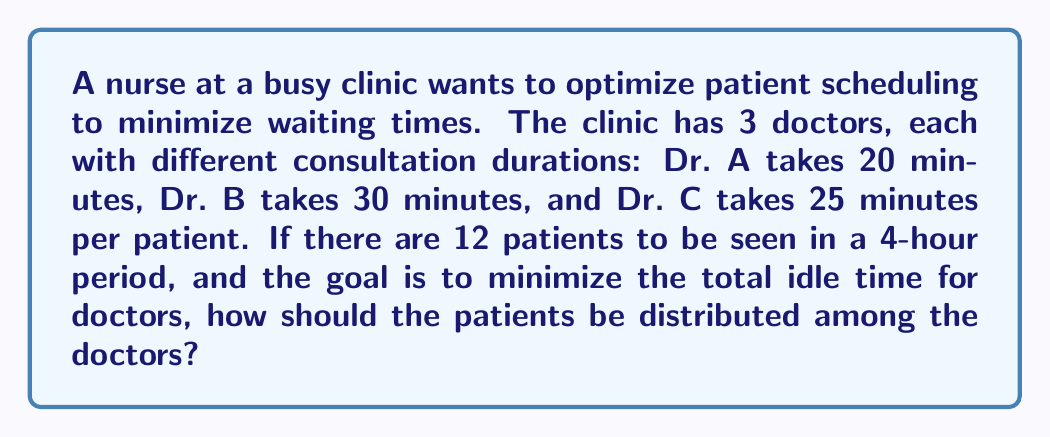Solve this math problem. To solve this problem, we need to follow these steps:

1. Calculate the total available time for all doctors:
   $4 \text{ hours} = 240 \text{ minutes}$

2. Set up variables:
   Let $x$, $y$, and $z$ be the number of patients seen by Dr. A, B, and C respectively.

3. Create constraints:
   - Total patients: $x + y + z = 12$
   - Time constraints:
     Dr. A: $20x \leq 240$
     Dr. B: $30y \leq 240$
     Dr. C: $25z \leq 240$

4. Optimize to minimize idle time:
   Idle time = $240 - 20x + 240 - 30y + 240 - 25z$
             = $720 - 20x - 30y - 25z$

5. Solve the linear programming problem:
   Maximize: $20x + 30y + 25z$
   Subject to:
   $x + y + z = 12$
   $20x \leq 240$
   $30y \leq 240$
   $25z \leq 240$
   $x, y, z \geq 0$ and integers

6. The optimal solution is:
   $x = 7$ (Dr. A sees 7 patients)
   $y = 3$ (Dr. B sees 3 patients)
   $z = 2$ (Dr. C sees 2 patients)

This distribution ensures that each doctor's time is fully utilized, minimizing idle time.
Answer: The optimal distribution of patients is: 7 patients for Dr. A, 3 patients for Dr. B, and 2 patients for Dr. C. 